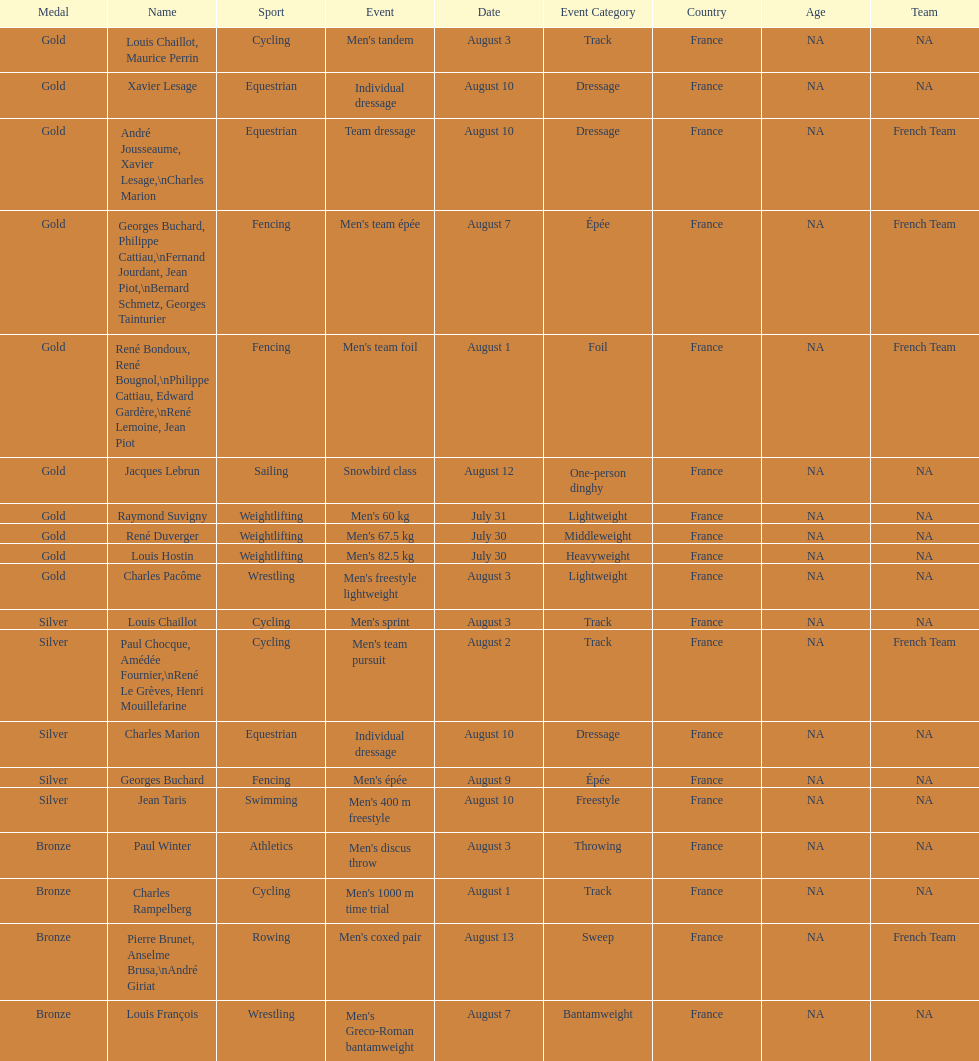Which event won the most medals? Cycling. 